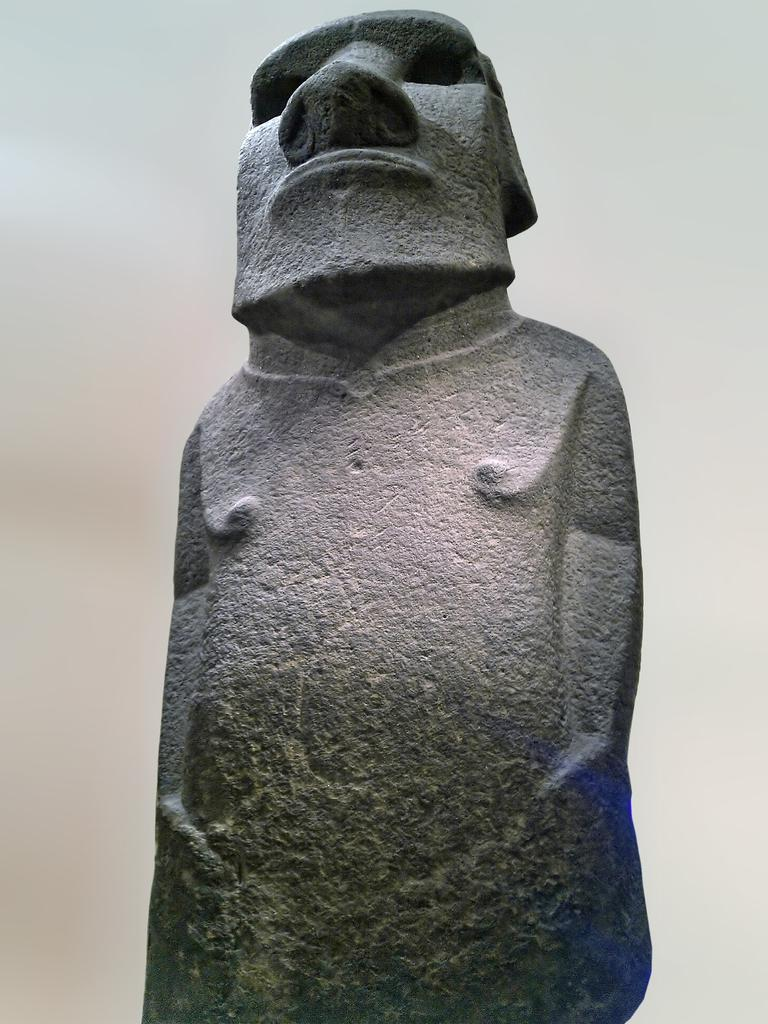What is the main subject of the image? There is a sculpture of a person in the center of the image. What color is the background of the image? The background of the image is white in color. What type of stitch is used to create the sculpture in the image? There is no information about the type of stitch used in the image, as it features a sculpture of a person and not a stitched object. 